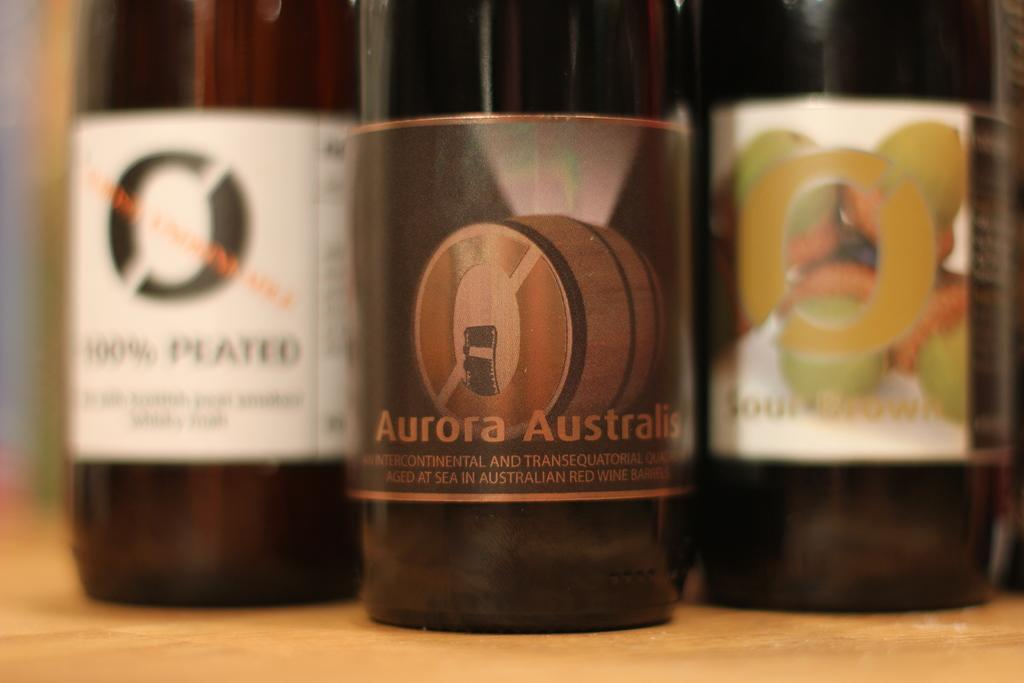<image>
Create a compact narrative representing the image presented. Bottle of Aurora Australis placed in between two other bottles. 